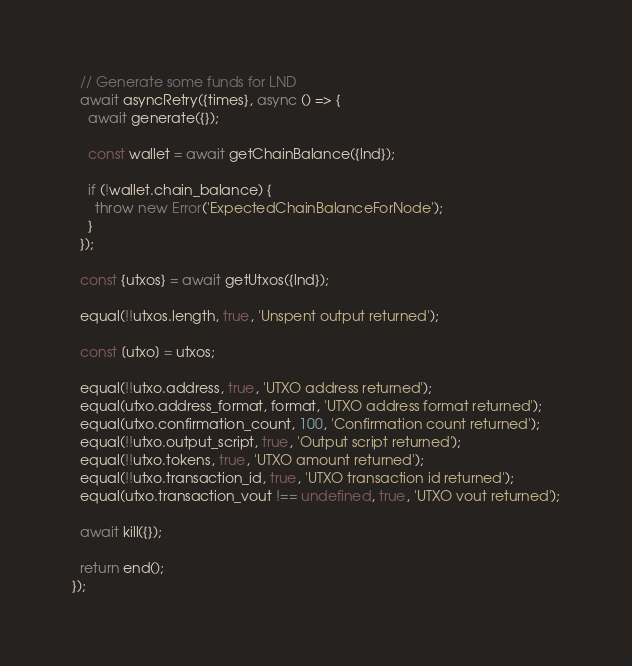Convert code to text. <code><loc_0><loc_0><loc_500><loc_500><_JavaScript_>  // Generate some funds for LND
  await asyncRetry({times}, async () => {
    await generate({});

    const wallet = await getChainBalance({lnd});

    if (!wallet.chain_balance) {
      throw new Error('ExpectedChainBalanceForNode');
    }
  });

  const {utxos} = await getUtxos({lnd});

  equal(!!utxos.length, true, 'Unspent output returned');

  const [utxo] = utxos;

  equal(!!utxo.address, true, 'UTXO address returned');
  equal(utxo.address_format, format, 'UTXO address format returned');
  equal(utxo.confirmation_count, 100, 'Confirmation count returned');
  equal(!!utxo.output_script, true, 'Output script returned');
  equal(!!utxo.tokens, true, 'UTXO amount returned');
  equal(!!utxo.transaction_id, true, 'UTXO transaction id returned');
  equal(utxo.transaction_vout !== undefined, true, 'UTXO vout returned');

  await kill({});

  return end();
});
</code> 